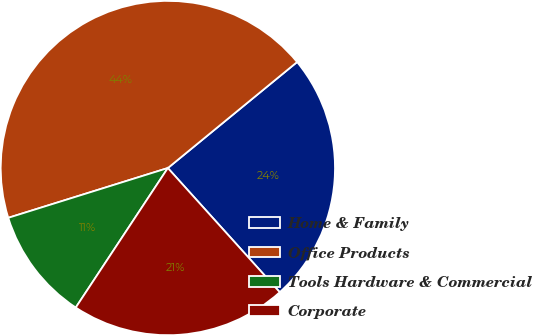<chart> <loc_0><loc_0><loc_500><loc_500><pie_chart><fcel>Home & Family<fcel>Office Products<fcel>Tools Hardware & Commercial<fcel>Corporate<nl><fcel>24.26%<fcel>43.88%<fcel>10.9%<fcel>20.96%<nl></chart> 